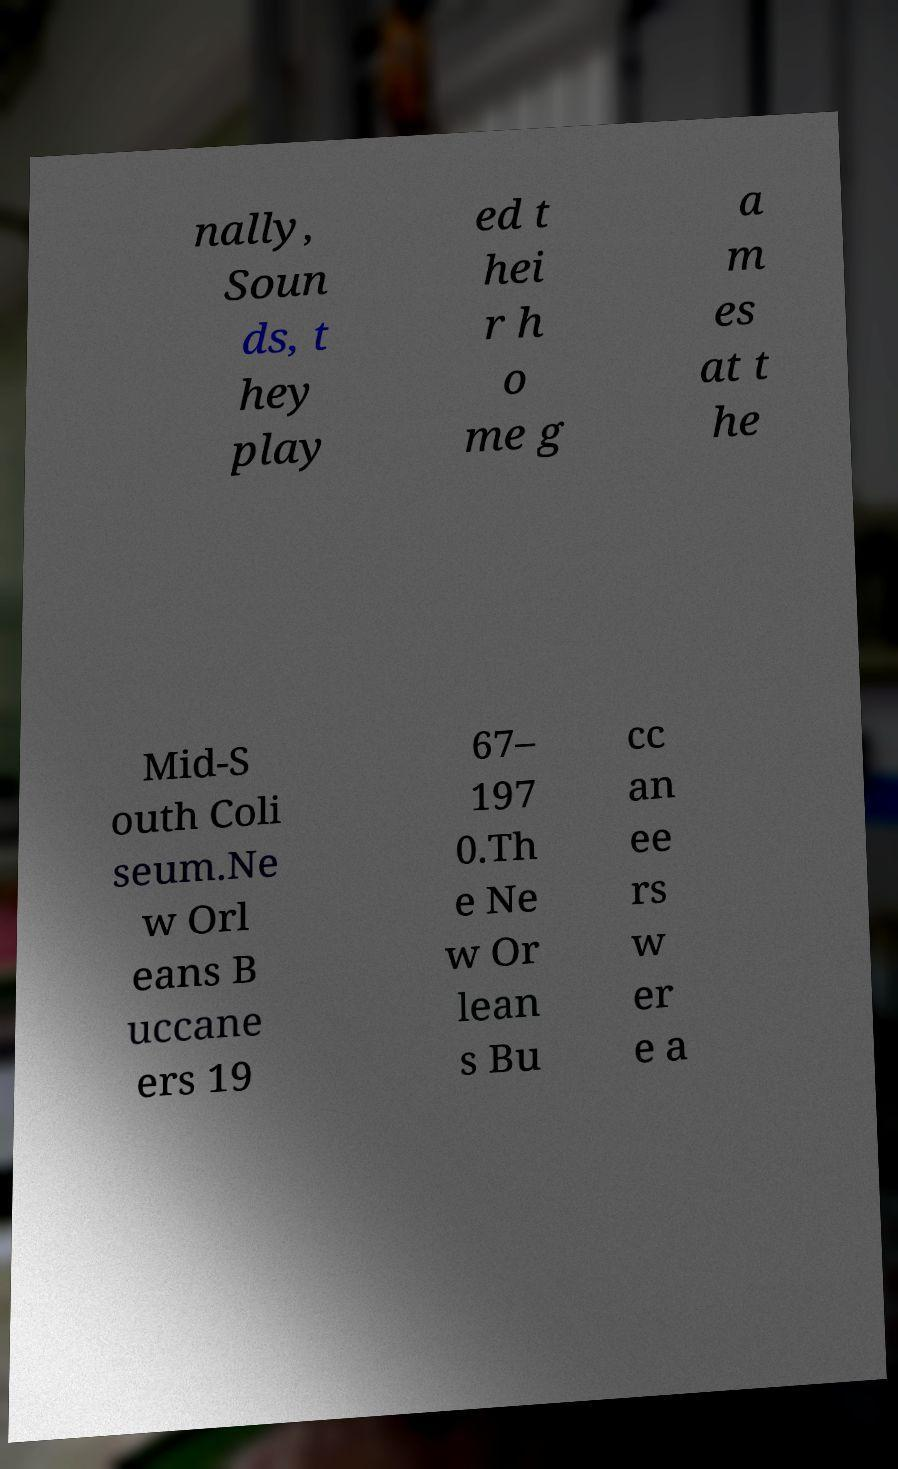Please read and relay the text visible in this image. What does it say? nally, Soun ds, t hey play ed t hei r h o me g a m es at t he Mid-S outh Coli seum.Ne w Orl eans B uccane ers 19 67– 197 0.Th e Ne w Or lean s Bu cc an ee rs w er e a 